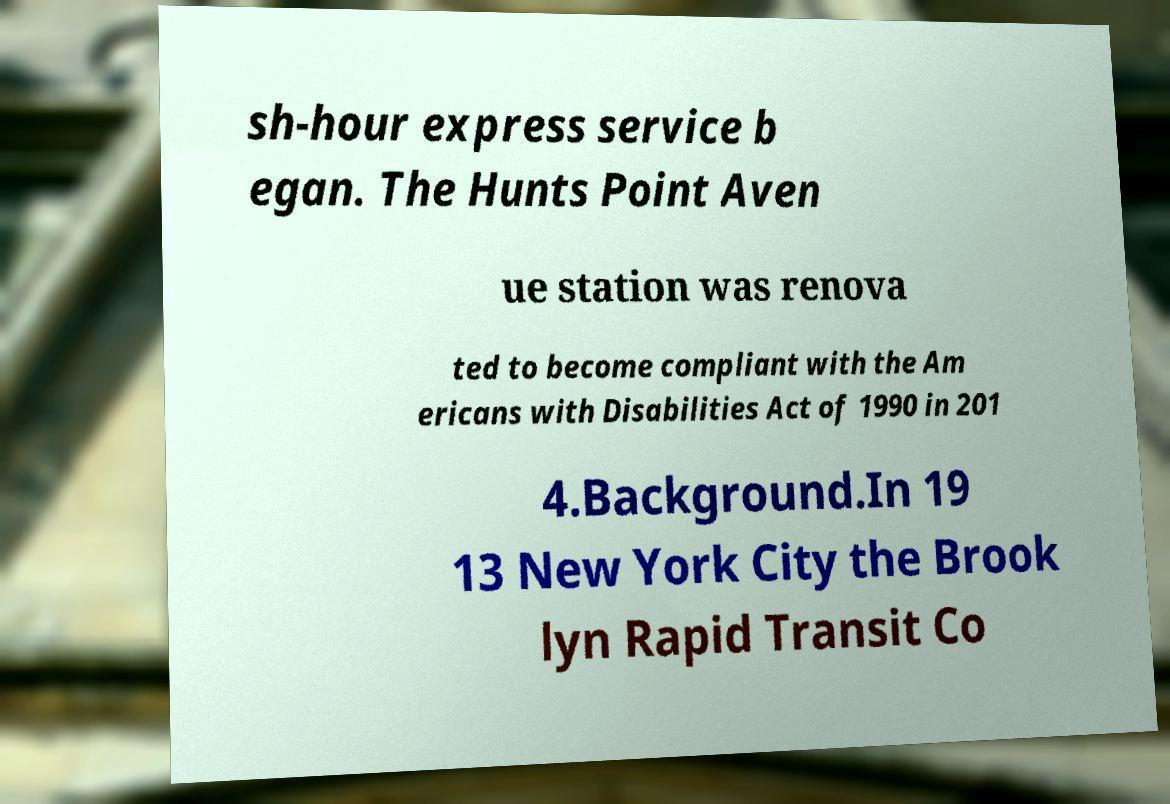Can you accurately transcribe the text from the provided image for me? sh-hour express service b egan. The Hunts Point Aven ue station was renova ted to become compliant with the Am ericans with Disabilities Act of 1990 in 201 4.Background.In 19 13 New York City the Brook lyn Rapid Transit Co 